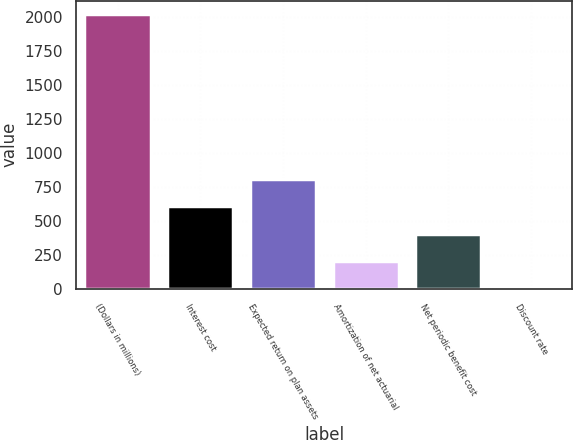Convert chart. <chart><loc_0><loc_0><loc_500><loc_500><bar_chart><fcel>(Dollars in millions)<fcel>Interest cost<fcel>Expected return on plan assets<fcel>Amortization of net actuarial<fcel>Net periodic benefit cost<fcel>Discount rate<nl><fcel>2017<fcel>606.88<fcel>808.32<fcel>204<fcel>405.44<fcel>2.56<nl></chart> 